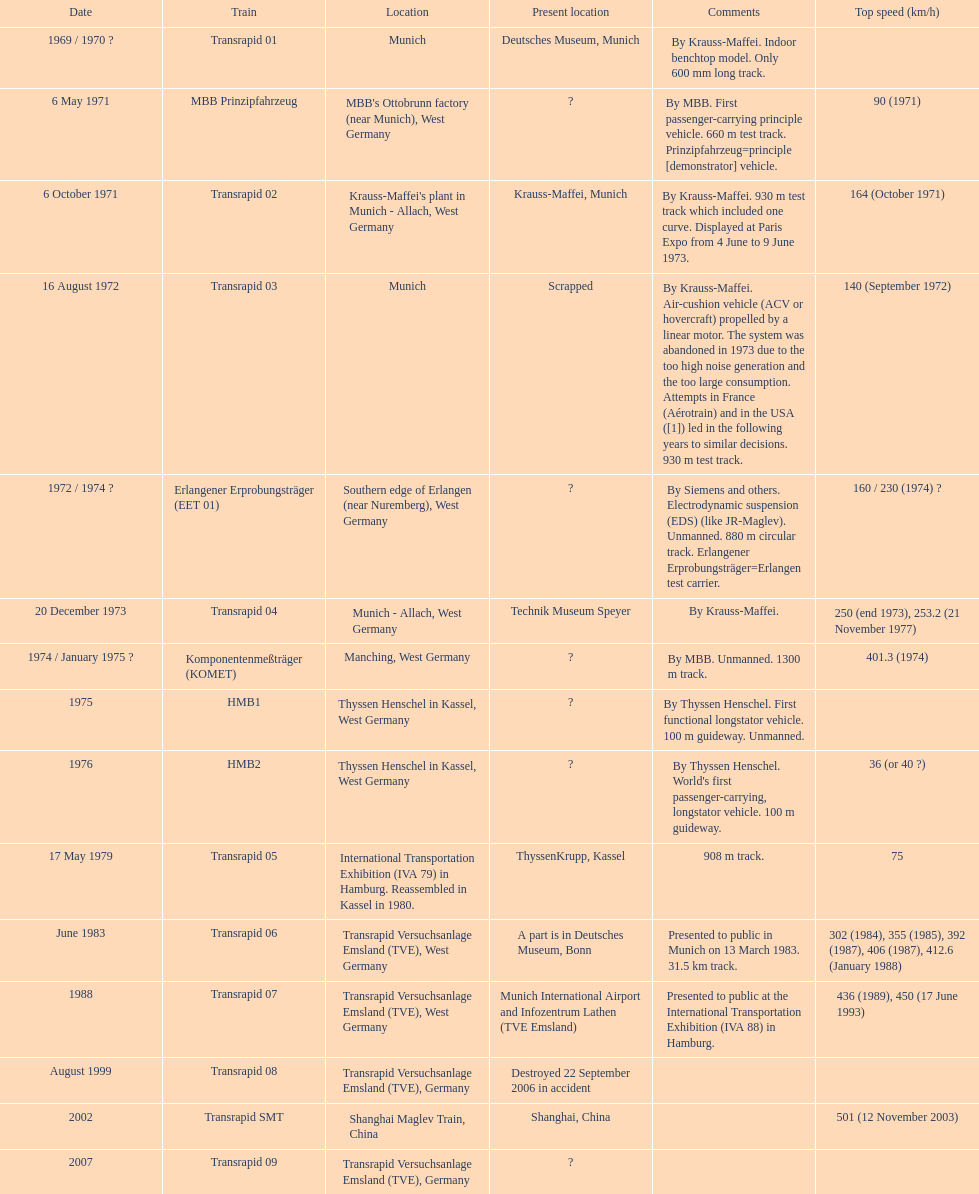How many trains listed have the same speed as the hmb2? 0. 